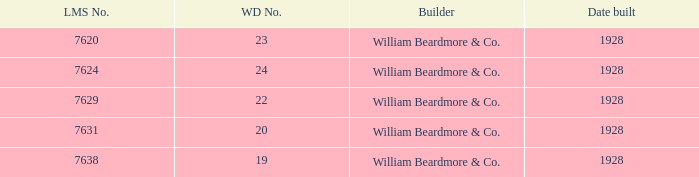For 24 wd items, what is the total quantity of serial numbers? 1.0. 